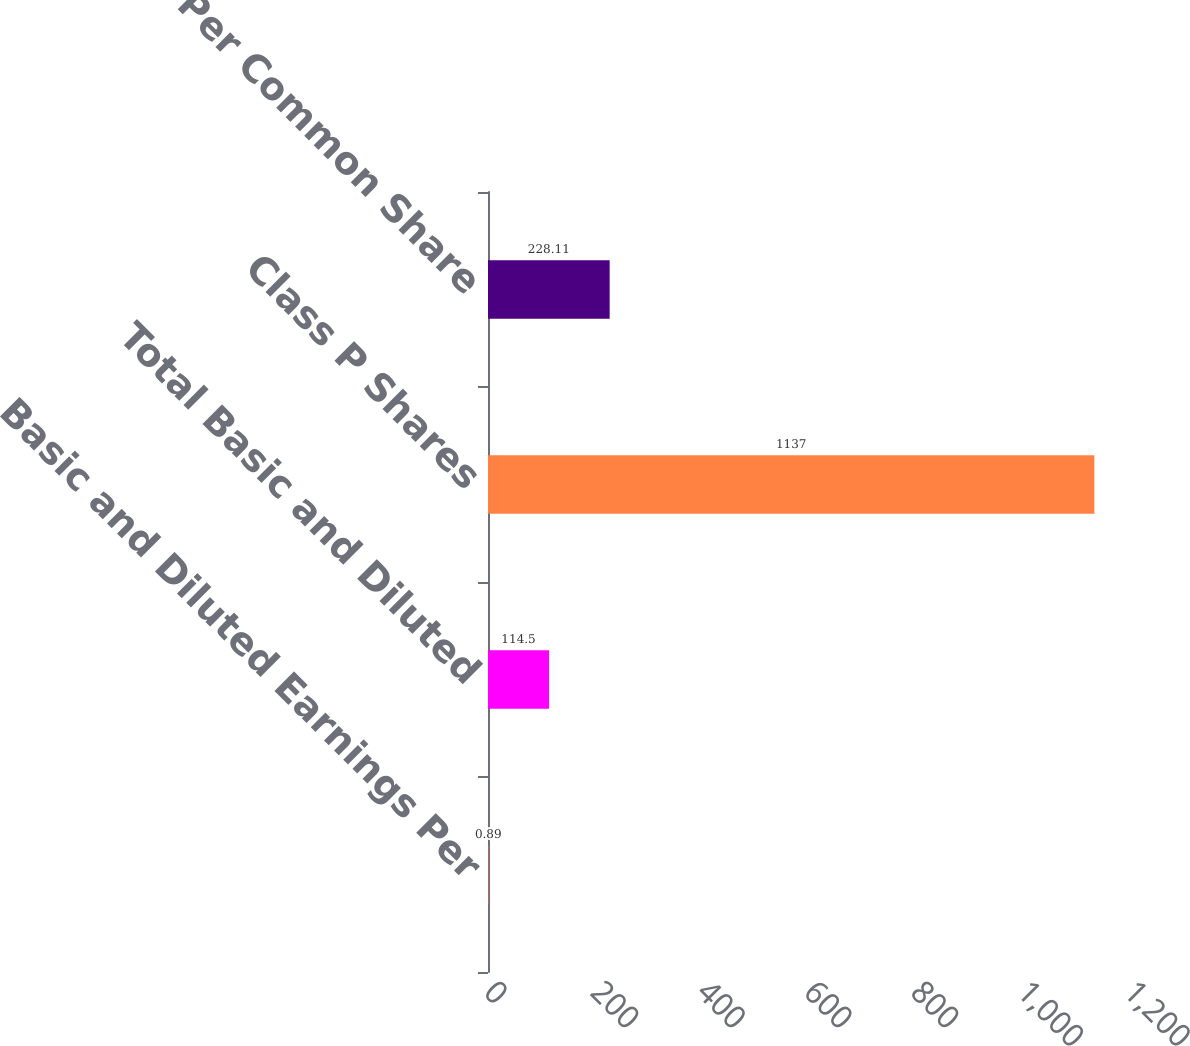Convert chart to OTSL. <chart><loc_0><loc_0><loc_500><loc_500><bar_chart><fcel>Basic and Diluted Earnings Per<fcel>Total Basic and Diluted<fcel>Class P Shares<fcel>Dividends Per Common Share<nl><fcel>0.89<fcel>114.5<fcel>1137<fcel>228.11<nl></chart> 